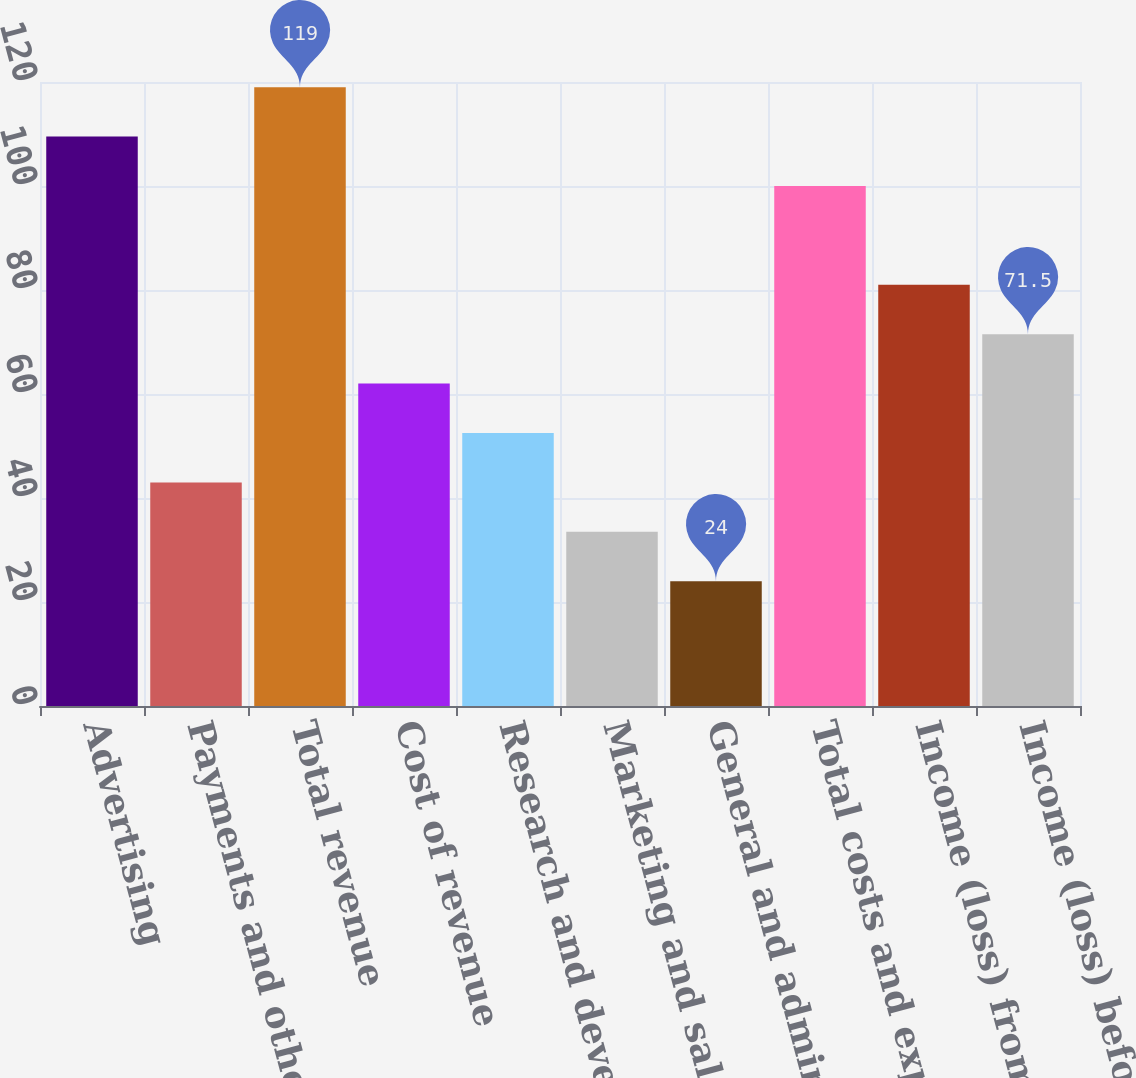<chart> <loc_0><loc_0><loc_500><loc_500><bar_chart><fcel>Advertising<fcel>Payments and other fees<fcel>Total revenue<fcel>Cost of revenue<fcel>Research and development<fcel>Marketing and sales<fcel>General and administrative<fcel>Total costs and expenses<fcel>Income (loss) from operations<fcel>Income (loss) before provision<nl><fcel>109.5<fcel>43<fcel>119<fcel>62<fcel>52.5<fcel>33.5<fcel>24<fcel>100<fcel>81<fcel>71.5<nl></chart> 